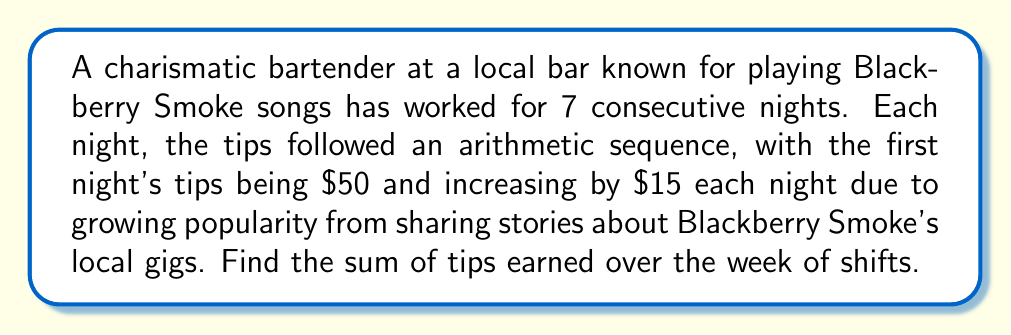Provide a solution to this math problem. Let's approach this step-by-step using the arithmetic sequence formula:

1) We have an arithmetic sequence where:
   $a_1 = 50$ (first term)
   $d = 15$ (common difference)
   $n = 7$ (number of terms)

2) The formula for the sum of an arithmetic sequence is:

   $$S_n = \frac{n}{2}(a_1 + a_n)$$

   where $a_n$ is the last term.

3) To find $a_n$, we use the formula:

   $$a_n = a_1 + (n-1)d$$
   $$a_7 = 50 + (7-1)15 = 50 + 90 = 140$$

4) Now we can substitute into our sum formula:

   $$S_7 = \frac{7}{2}(50 + 140)$$

5) Simplify:
   $$S_7 = \frac{7}{2}(190) = 7(95) = 665$$

Therefore, the sum of tips earned over the week is $665.
Answer: $665 